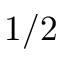<formula> <loc_0><loc_0><loc_500><loc_500>1 / 2</formula> 